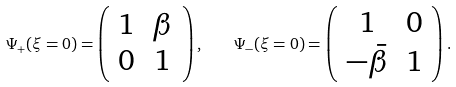Convert formula to latex. <formula><loc_0><loc_0><loc_500><loc_500>\Psi _ { + } ( \xi = 0 ) = \left ( \begin{array} { c c } 1 & \beta \\ 0 & 1 \end{array} \right ) , \quad \Psi _ { - } ( \xi = 0 ) = \left ( \begin{array} { c c } 1 & 0 \\ - \bar { \beta } & 1 \end{array} \right ) .</formula> 